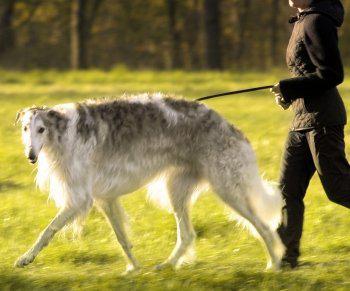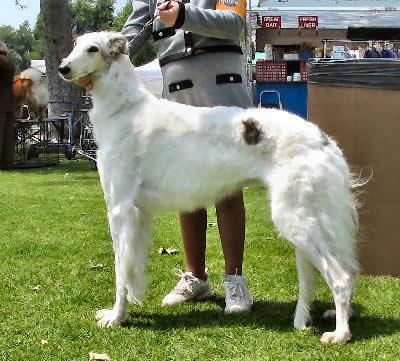The first image is the image on the left, the second image is the image on the right. Analyze the images presented: Is the assertion "There is only one dog in each picture." valid? Answer yes or no. Yes. The first image is the image on the left, the second image is the image on the right. Given the left and right images, does the statement "There are more dogs outside in the image on the right." hold true? Answer yes or no. No. The first image is the image on the left, the second image is the image on the right. Evaluate the accuracy of this statement regarding the images: "There are two dogs in total.". Is it true? Answer yes or no. Yes. The first image is the image on the left, the second image is the image on the right. For the images displayed, is the sentence "One image includes at least twice as many hounds in the foreground as the other image." factually correct? Answer yes or no. No. The first image is the image on the left, the second image is the image on the right. For the images displayed, is the sentence "There are two dogs total, facing both left and right." factually correct? Answer yes or no. No. The first image is the image on the left, the second image is the image on the right. For the images displayed, is the sentence "Each image shows exactly one dog standing on all fours outdoors." factually correct? Answer yes or no. Yes. The first image is the image on the left, the second image is the image on the right. Analyze the images presented: Is the assertion "One dog is facing left and one dog is facing right." valid? Answer yes or no. No. The first image is the image on the left, the second image is the image on the right. For the images displayed, is the sentence "There are the same number of hounds in the left and right images." factually correct? Answer yes or no. Yes. The first image is the image on the left, the second image is the image on the right. For the images shown, is this caption "The lefthand image contains one gray-and-white hound standing with its body turned leftward and face to the camera." true? Answer yes or no. Yes. 